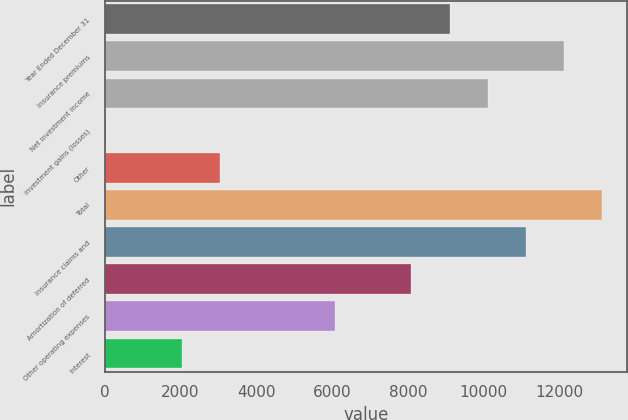Convert chart to OTSL. <chart><loc_0><loc_0><loc_500><loc_500><bar_chart><fcel>Year Ended December 31<fcel>Insurance premiums<fcel>Net investment income<fcel>Investment gains (losses)<fcel>Other<fcel>Total<fcel>Insurance claims and<fcel>Amortization of deferred<fcel>Other operating expenses<fcel>Interest<nl><fcel>9104.4<fcel>12130.2<fcel>10113<fcel>27<fcel>3052.8<fcel>13138.8<fcel>11121.6<fcel>8095.8<fcel>6078.6<fcel>2044.2<nl></chart> 